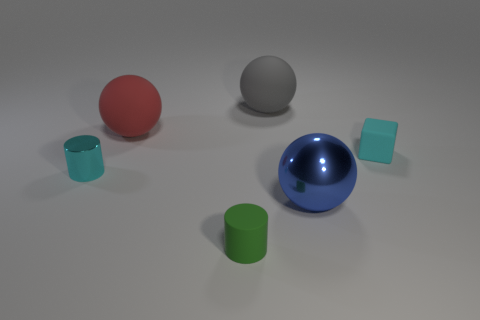Add 3 large cyan matte cylinders. How many objects exist? 9 Subtract all cylinders. How many objects are left? 4 Subtract all green rubber objects. Subtract all brown blocks. How many objects are left? 5 Add 2 large red rubber spheres. How many large red rubber spheres are left? 3 Add 6 red metal things. How many red metal things exist? 6 Subtract 0 purple blocks. How many objects are left? 6 